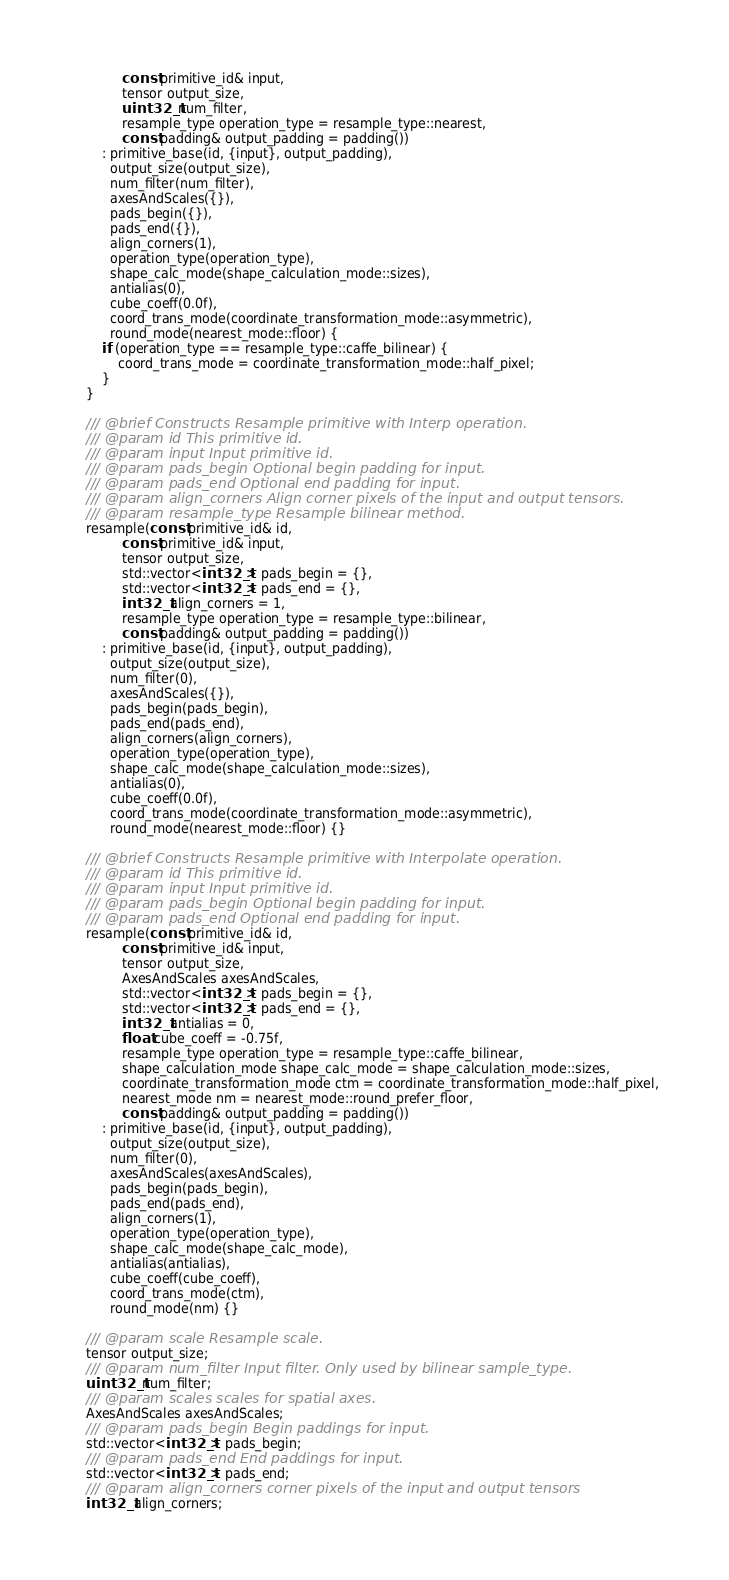Convert code to text. <code><loc_0><loc_0><loc_500><loc_500><_C++_>             const primitive_id& input,
             tensor output_size,
             uint32_t num_filter,
             resample_type operation_type = resample_type::nearest,
             const padding& output_padding = padding())
        : primitive_base(id, {input}, output_padding),
          output_size(output_size),
          num_filter(num_filter),
          axesAndScales({}),
          pads_begin({}),
          pads_end({}),
          align_corners(1),
          operation_type(operation_type),
          shape_calc_mode(shape_calculation_mode::sizes),
          antialias(0),
          cube_coeff(0.0f),
          coord_trans_mode(coordinate_transformation_mode::asymmetric),
          round_mode(nearest_mode::floor) {
        if (operation_type == resample_type::caffe_bilinear) {
            coord_trans_mode = coordinate_transformation_mode::half_pixel;
        }
    }

    /// @brief Constructs Resample primitive with Interp operation.
    /// @param id This primitive id.
    /// @param input Input primitive id.
    /// @param pads_begin Optional begin padding for input.
    /// @param pads_end Optional end padding for input.
    /// @param align_corners Align corner pixels of the input and output tensors.
    /// @param resample_type Resample bilinear method.
    resample(const primitive_id& id,
             const primitive_id& input,
             tensor output_size,
             std::vector<int32_t> pads_begin = {},
             std::vector<int32_t> pads_end = {},
             int32_t align_corners = 1,
             resample_type operation_type = resample_type::bilinear,
             const padding& output_padding = padding())
        : primitive_base(id, {input}, output_padding),
          output_size(output_size),
          num_filter(0),
          axesAndScales({}),
          pads_begin(pads_begin),
          pads_end(pads_end),
          align_corners(align_corners),
          operation_type(operation_type),
          shape_calc_mode(shape_calculation_mode::sizes),
          antialias(0),
          cube_coeff(0.0f),
          coord_trans_mode(coordinate_transformation_mode::asymmetric),
          round_mode(nearest_mode::floor) {}

    /// @brief Constructs Resample primitive with Interpolate operation.
    /// @param id This primitive id.
    /// @param input Input primitive id.
    /// @param pads_begin Optional begin padding for input.
    /// @param pads_end Optional end padding for input.
    resample(const primitive_id& id,
             const primitive_id& input,
             tensor output_size,
             AxesAndScales axesAndScales,
             std::vector<int32_t> pads_begin = {},
             std::vector<int32_t> pads_end = {},
             int32_t antialias = 0,
             float cube_coeff = -0.75f,
             resample_type operation_type = resample_type::caffe_bilinear,
             shape_calculation_mode shape_calc_mode = shape_calculation_mode::sizes,
             coordinate_transformation_mode ctm = coordinate_transformation_mode::half_pixel,
             nearest_mode nm = nearest_mode::round_prefer_floor,
             const padding& output_padding = padding())
        : primitive_base(id, {input}, output_padding),
          output_size(output_size),
          num_filter(0),
          axesAndScales(axesAndScales),
          pads_begin(pads_begin),
          pads_end(pads_end),
          align_corners(1),
          operation_type(operation_type),
          shape_calc_mode(shape_calc_mode),
          antialias(antialias),
          cube_coeff(cube_coeff),
          coord_trans_mode(ctm),
          round_mode(nm) {}

    /// @param scale Resample scale.
    tensor output_size;
    /// @param num_filter Input filter. Only used by bilinear sample_type.
    uint32_t num_filter;
    /// @param scales scales for spatial axes.
    AxesAndScales axesAndScales;
    /// @param pads_begin Begin paddings for input.
    std::vector<int32_t> pads_begin;
    /// @param pads_end End paddings for input.
    std::vector<int32_t> pads_end;
    /// @param align_corners corner pixels of the input and output tensors
    int32_t align_corners;</code> 